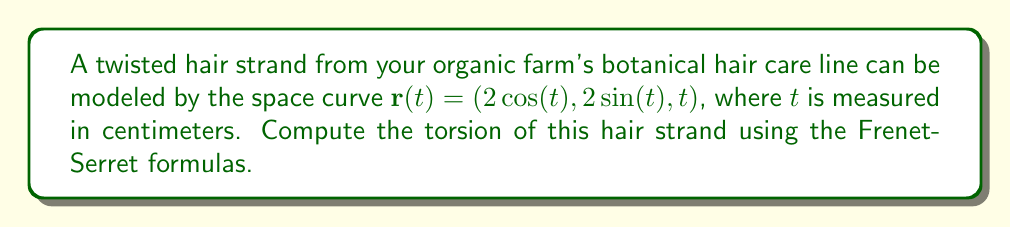Solve this math problem. To compute the torsion of the hair strand, we'll use the Frenet-Serret formula for torsion:

$$\tau = \frac{\mathbf{r}'(t) \cdot (\mathbf{r}''(t) \times \mathbf{r}'''(t))}{|\mathbf{r}'(t) \times \mathbf{r}''(t)|^2}$$

Step 1: Calculate $\mathbf{r}'(t)$, $\mathbf{r}''(t)$, and $\mathbf{r}'''(t)$

$\mathbf{r}'(t) = (-2\sin(t), 2\cos(t), 1)$
$\mathbf{r}''(t) = (-2\cos(t), -2\sin(t), 0)$
$\mathbf{r}'''(t) = (2\sin(t), -2\cos(t), 0)$

Step 2: Compute $\mathbf{r}''(t) \times \mathbf{r}'''(t)$

$$\mathbf{r}''(t) \times \mathbf{r}'''(t) = \begin{vmatrix} 
\mathbf{i} & \mathbf{j} & \mathbf{k} \\
-2\cos(t) & -2\sin(t) & 0 \\
2\sin(t) & -2\cos(t) & 0
\end{vmatrix} = (0, 0, -4)$$

Step 3: Calculate $\mathbf{r}'(t) \cdot (\mathbf{r}''(t) \times \mathbf{r}'''(t))$

$\mathbf{r}'(t) \cdot (\mathbf{r}''(t) \times \mathbf{r}'''(t)) = (-2\sin(t), 2\cos(t), 1) \cdot (0, 0, -4) = -4$

Step 4: Compute $|\mathbf{r}'(t) \times \mathbf{r}''(t)|^2$

$$\mathbf{r}'(t) \times \mathbf{r}''(t) = \begin{vmatrix} 
\mathbf{i} & \mathbf{j} & \mathbf{k} \\
-2\sin(t) & 2\cos(t) & 1 \\
-2\cos(t) & -2\sin(t) & 0
\end{vmatrix} = (-2\sin(t), -2\cos(t), -4)$$

$|\mathbf{r}'(t) \times \mathbf{r}''(t)|^2 = (-2\sin(t))^2 + (-2\cos(t))^2 + (-4)^2 = 4\sin^2(t) + 4\cos^2(t) + 16 = 20$

Step 5: Calculate the torsion

$$\tau = \frac{\mathbf{r}'(t) \cdot (\mathbf{r}''(t) \times \mathbf{r}'''(t))}{|\mathbf{r}'(t) \times \mathbf{r}''(t)|^2} = \frac{-4}{20} = -\frac{1}{5}$$

The torsion is constant and equal to $-\frac{1}{5}$ cm$^{-1}$.
Answer: $-\frac{1}{5}$ cm$^{-1}$ 